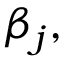Convert formula to latex. <formula><loc_0><loc_0><loc_500><loc_500>\beta _ { j } ,</formula> 